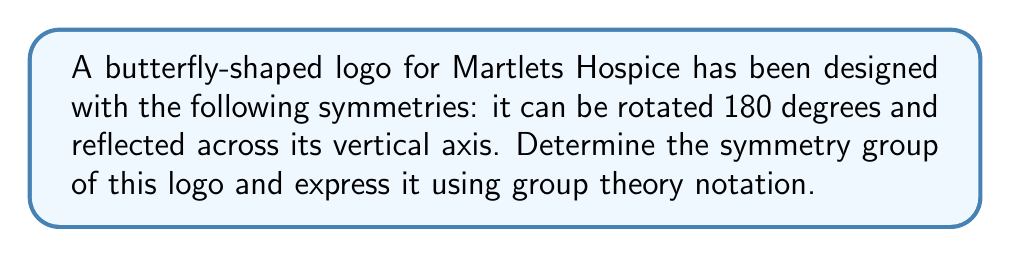Teach me how to tackle this problem. To determine the symmetry group of the butterfly-shaped logo, let's analyze its symmetries step-by-step:

1) First, let's identify the symmetry operations:
   - Identity (I): No change to the logo
   - 180-degree rotation (R): Rotating the logo 180 degrees
   - Vertical reflection (V): Reflecting the logo across its vertical axis

2) These symmetries form a group. Let's verify the group properties:
   - Closure: Applying any two of these operations always results in one of the operations
   - Associativity: This is inherent in geometric transformations
   - Identity: The identity operation I exists
   - Inverse: Each operation is its own inverse (I² = I, R² = I, V² = I)

3) Let's construct the group table:

   |   | I | R | V |
   |---|---|---|---|
   | I | I | R | V |
   | R | R | I | V |
   | V | V | V | I |

4) This group structure is isomorphic to the cyclic group $C_2$ (of order 2) direct product with itself: $C_2 \times C_2$

5) In abstract algebra notation, this group is often denoted as $V_4$, known as the Klein four-group

6) The group can also be described using the presentation:
   $$\langle R, V | R^2 = V^2 = I, RV = VR \rangle$$

This means the group is generated by R and V, subject to the relations that R and V both have order 2 and they commute with each other.
Answer: The symmetry group of the butterfly-shaped logo is the Klein four-group, $V_4 \cong C_2 \times C_2$, with the presentation $\langle R, V | R^2 = V^2 = I, RV = VR \rangle$. 